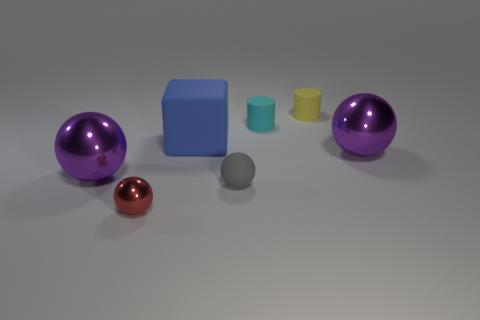Subtract all red spheres. How many spheres are left? 3 Subtract all green cylinders. How many purple spheres are left? 2 Add 2 matte things. How many objects exist? 9 Subtract all purple spheres. How many spheres are left? 2 Subtract all cylinders. How many objects are left? 5 Subtract 1 balls. How many balls are left? 3 Subtract 0 yellow spheres. How many objects are left? 7 Subtract all yellow cylinders. Subtract all blue balls. How many cylinders are left? 1 Subtract all tiny red balls. Subtract all tiny matte objects. How many objects are left? 3 Add 4 metallic balls. How many metallic balls are left? 7 